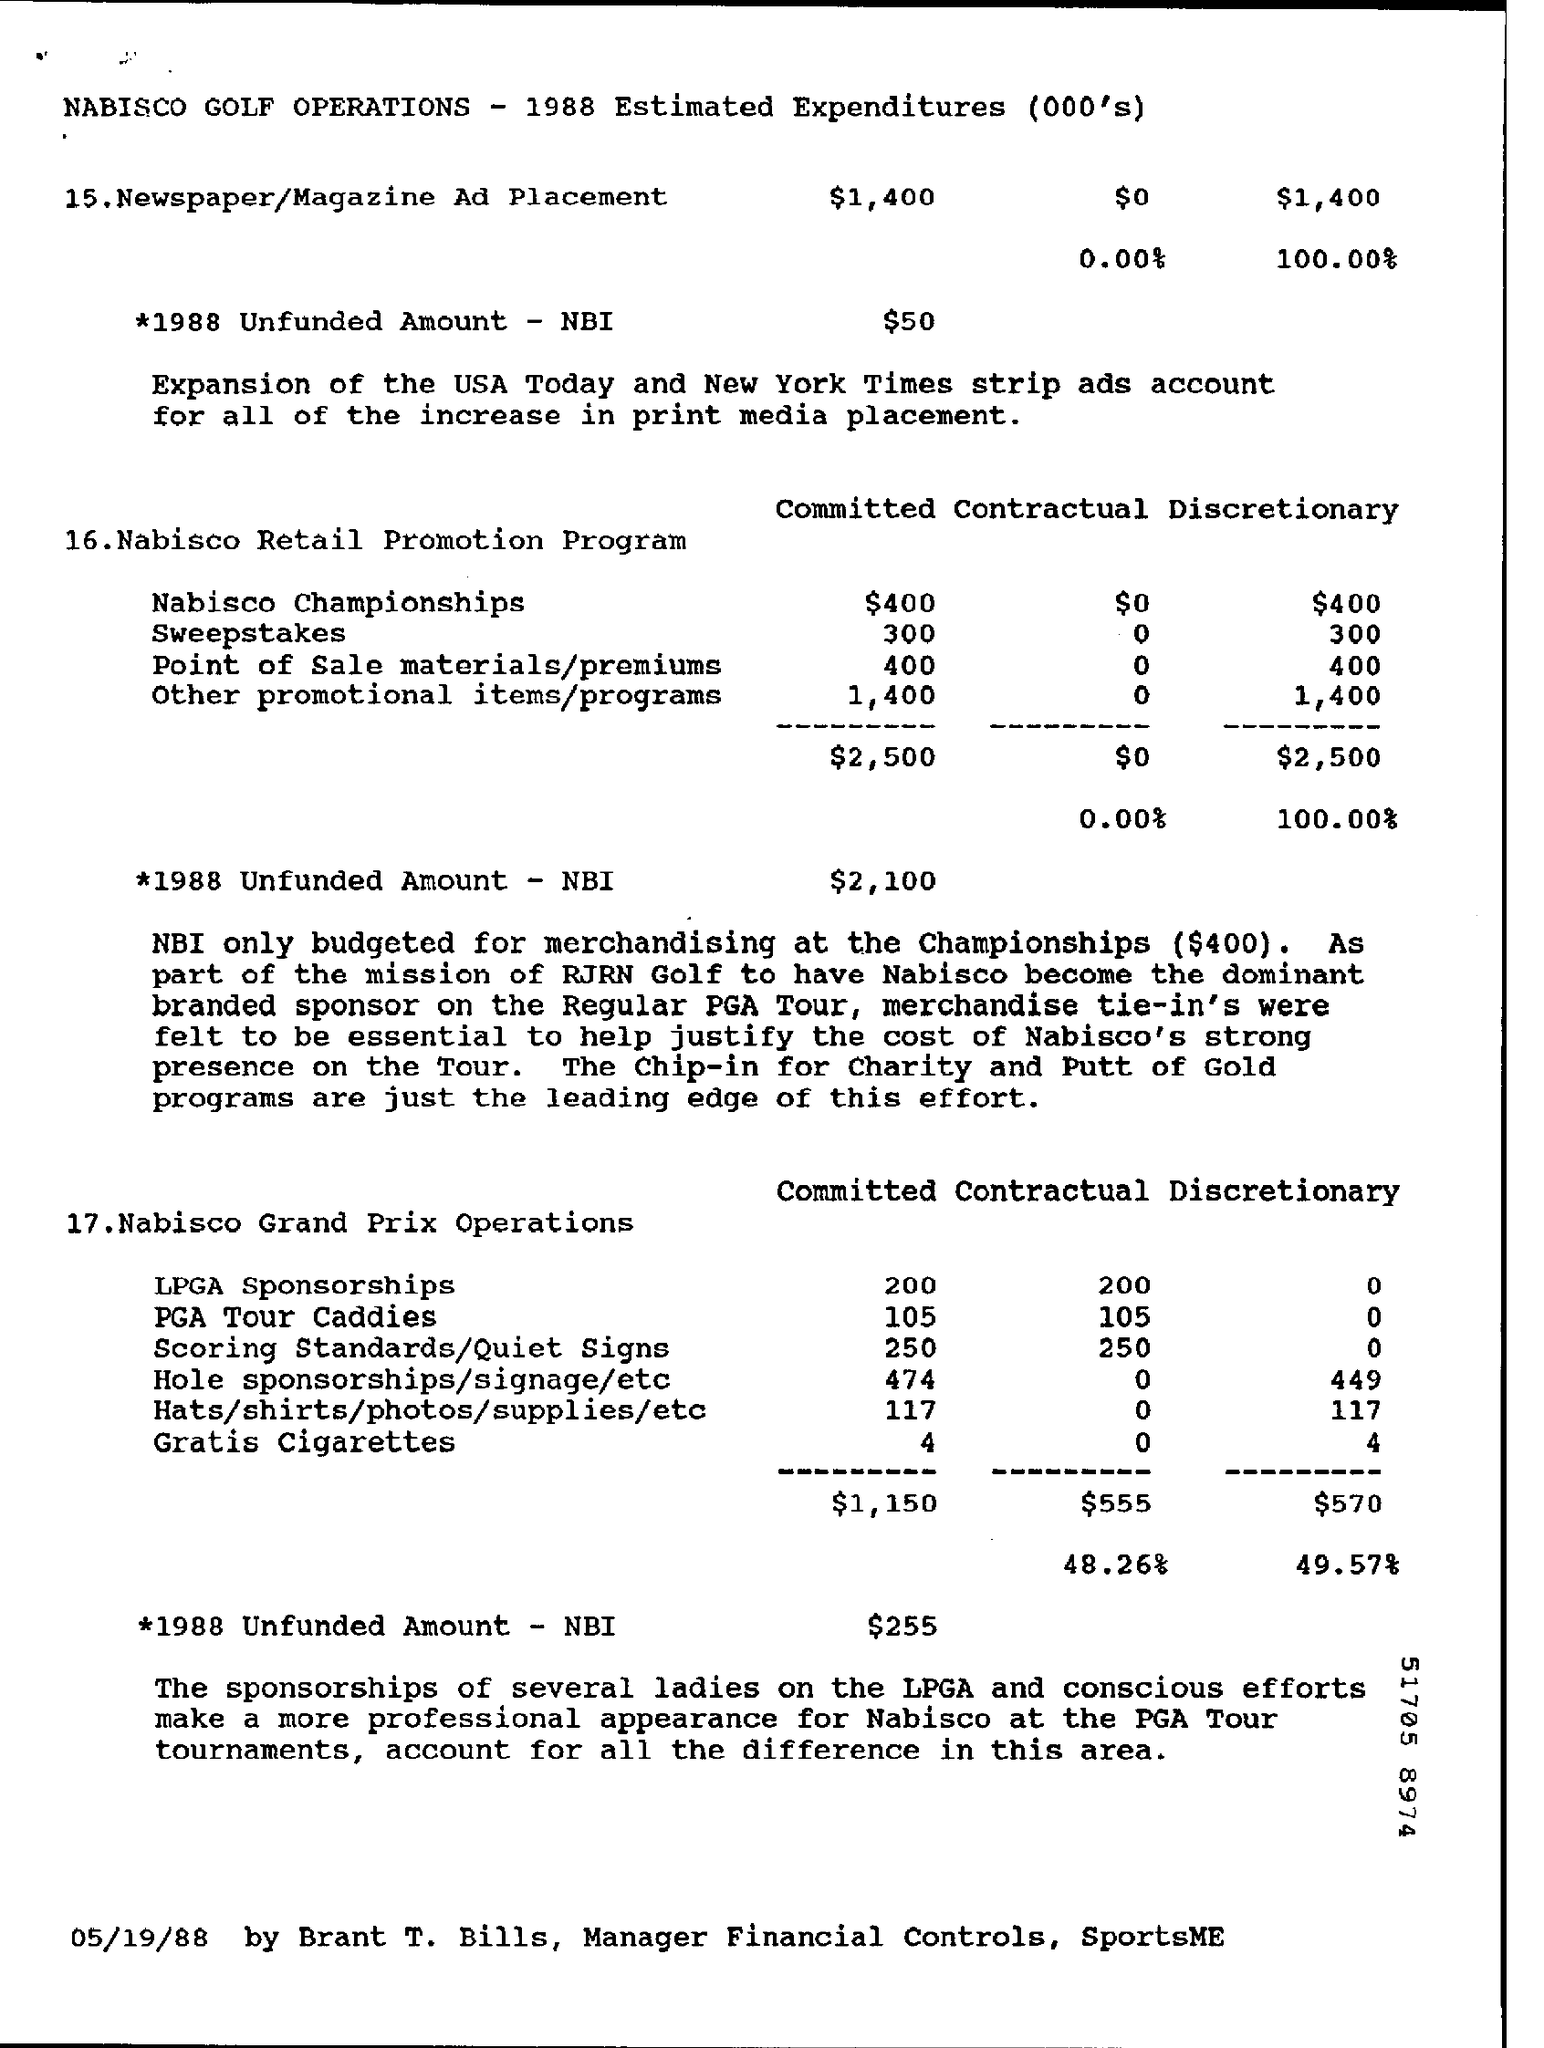What is the Committed for Nabisco Championships?
Keep it short and to the point. 400. What is the Committed for Sweepstakes?
Ensure brevity in your answer.  300. What is the Committed for Point of Sale materials/premiums?
Make the answer very short. 400. What is the Committed for Other promotional items/programs?
Your response must be concise. 1,400. What is the Committed for LPGA Sponsorships?
Offer a terse response. 200. What is the Committed for PGA Tour Caddies?
Keep it short and to the point. 105. What is the Committed for Gratis Cigarettes?
Offer a very short reply. 4. What is the Committed for Hole sponsorships/signage/etc?
Your answer should be very brief. 474. What is the Contractual for LPGA Sponsorships?
Offer a very short reply. 200. What is the Contractual for PGA Tour Caddies?
Provide a succinct answer. 105. 